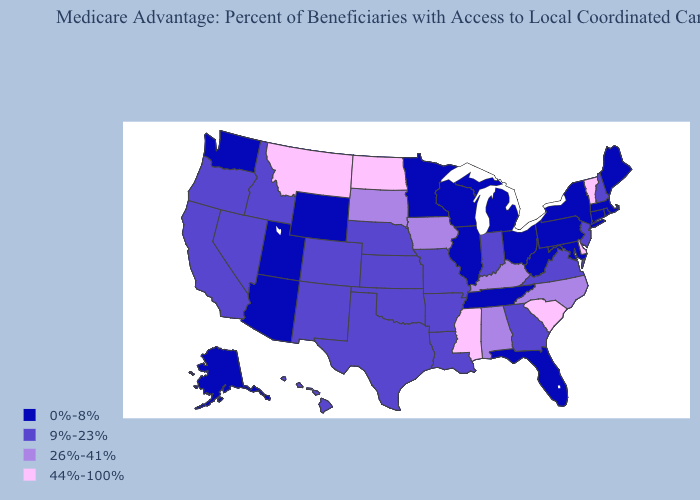Name the states that have a value in the range 44%-100%?
Give a very brief answer. Delaware, Mississippi, Montana, North Dakota, South Carolina, Vermont. What is the lowest value in the USA?
Answer briefly. 0%-8%. Which states have the highest value in the USA?
Answer briefly. Delaware, Mississippi, Montana, North Dakota, South Carolina, Vermont. What is the value of Vermont?
Keep it brief. 44%-100%. Which states have the lowest value in the USA?
Quick response, please. Connecticut, Florida, Illinois, Massachusetts, Maryland, Maine, Michigan, Minnesota, New York, Ohio, Pennsylvania, Rhode Island, Alaska, Tennessee, Utah, Washington, Wisconsin, West Virginia, Wyoming, Arizona. What is the highest value in the MidWest ?
Write a very short answer. 44%-100%. Does Kansas have a lower value than Iowa?
Answer briefly. Yes. What is the value of Connecticut?
Short answer required. 0%-8%. Does the first symbol in the legend represent the smallest category?
Quick response, please. Yes. What is the value of Mississippi?
Short answer required. 44%-100%. Does Ohio have the lowest value in the MidWest?
Short answer required. Yes. Which states have the highest value in the USA?
Be succinct. Delaware, Mississippi, Montana, North Dakota, South Carolina, Vermont. Does Michigan have the highest value in the USA?
Be succinct. No. Name the states that have a value in the range 26%-41%?
Give a very brief answer. Iowa, Kentucky, North Carolina, South Dakota, Alabama. 